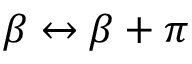<formula> <loc_0><loc_0><loc_500><loc_500>\beta \leftrightarrow \beta + \pi</formula> 